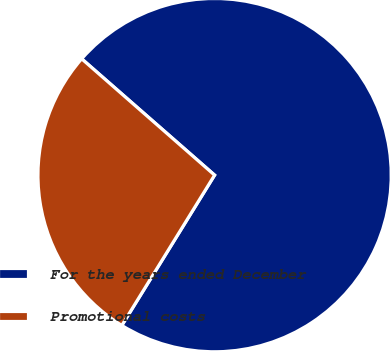Convert chart to OTSL. <chart><loc_0><loc_0><loc_500><loc_500><pie_chart><fcel>For the years ended December<fcel>Promotional costs<nl><fcel>72.36%<fcel>27.64%<nl></chart> 